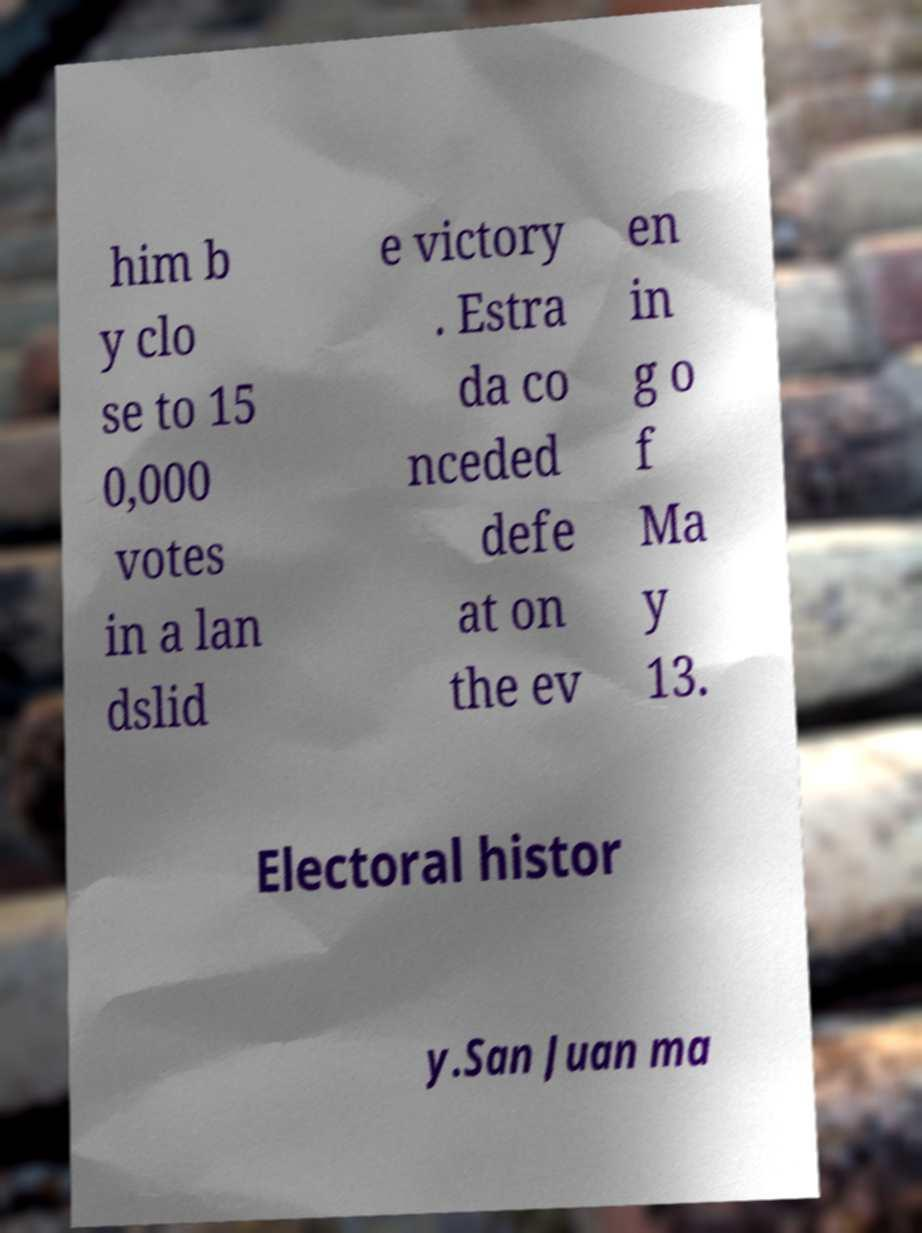Can you accurately transcribe the text from the provided image for me? him b y clo se to 15 0,000 votes in a lan dslid e victory . Estra da co nceded defe at on the ev en in g o f Ma y 13. Electoral histor y.San Juan ma 